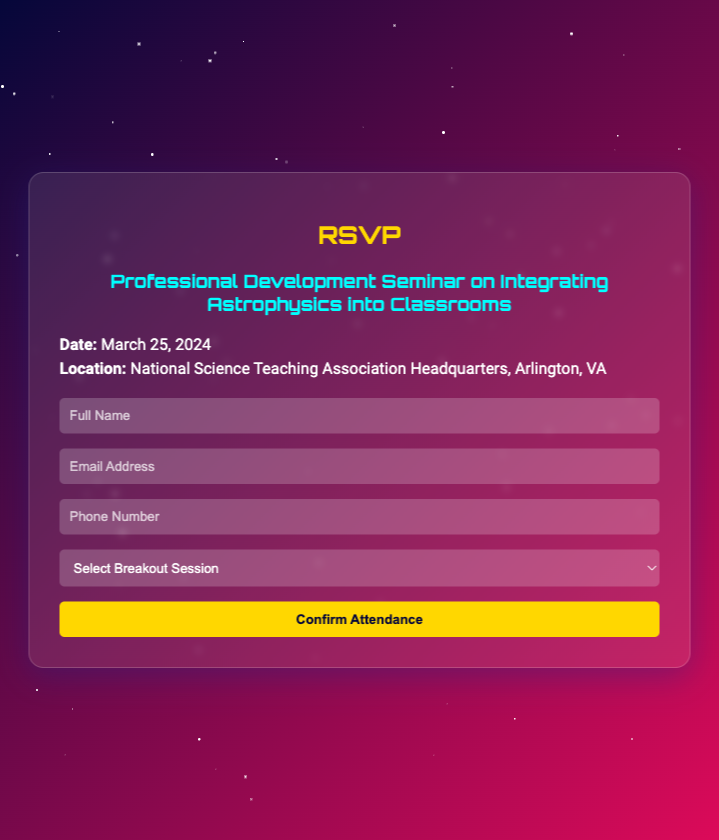What is the date of the seminar? The date of the seminar is stated in the details section of the document.
Answer: March 25, 2024 Where is the seminar being held? The location of the seminar is mentioned in the details section of the document.
Answer: National Science Teaching Association Headquarters, Arlington, VA What is one breakout session topic? The document lists multiple breakout session topics under the form section.
Answer: Astrophysics in the K-12 Curriculum How many breakout session options are provided? The number of options can be counted from the dropdown in the RSVP form.
Answer: Four What color is the title of the seminar? The color of the seminar title is indicated in the styling of the document.
Answer: Cyan What will happen when the RSVP form is submitted? The interaction upon submission is explained in the script part of the document.
Answer: An alert will appear Is there a phone number field in the RSVP form? The presence of a field for phone number can be directly viewed in the form section.
Answer: Yes Who is the target audience for this seminar? The context of the seminar, targeting educators, helps infer the audience from the document.
Answer: Teachers What is the main purpose of the document? The main function of the RSVP card can be understood from its title and content.
Answer: Confirm attendance for a seminar 